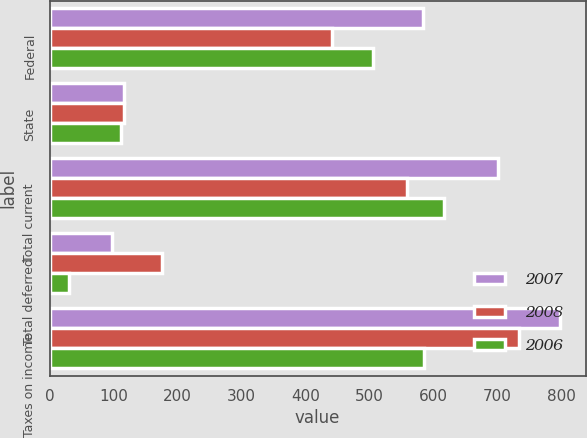Convert chart. <chart><loc_0><loc_0><loc_500><loc_500><stacked_bar_chart><ecel><fcel>Federal<fcel>State<fcel>Total current<fcel>Total deferred<fcel>Taxes on income<nl><fcel>2007<fcel>584<fcel>117<fcel>701<fcel>97<fcel>798<nl><fcel>2008<fcel>441<fcel>117<fcel>558<fcel>175<fcel>733<nl><fcel>2006<fcel>505<fcel>111<fcel>616<fcel>31<fcel>585<nl></chart> 